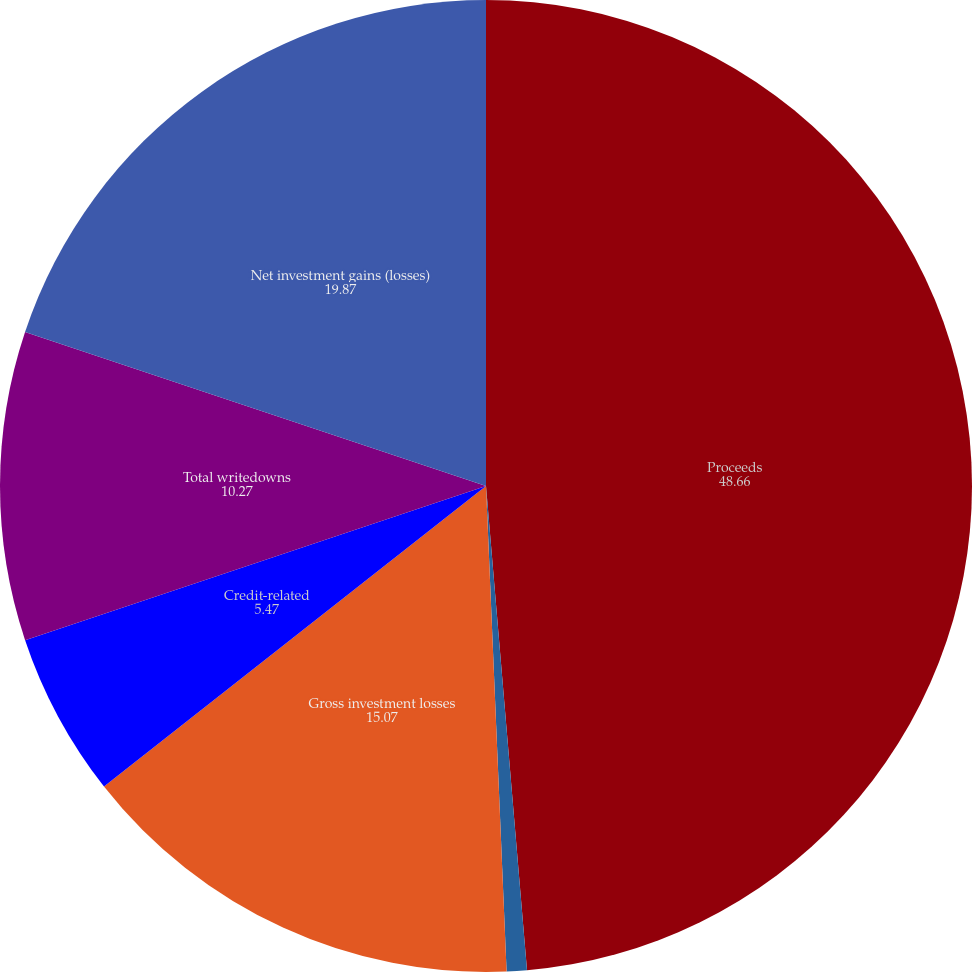Convert chart to OTSL. <chart><loc_0><loc_0><loc_500><loc_500><pie_chart><fcel>Proceeds<fcel>Gross investment gains<fcel>Gross investment losses<fcel>Credit-related<fcel>Total writedowns<fcel>Net investment gains (losses)<nl><fcel>48.66%<fcel>0.67%<fcel>15.07%<fcel>5.47%<fcel>10.27%<fcel>19.87%<nl></chart> 